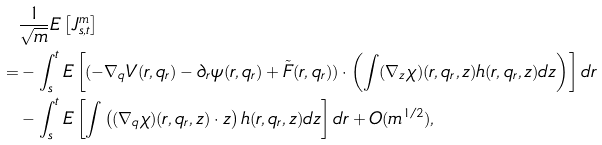Convert formula to latex. <formula><loc_0><loc_0><loc_500><loc_500>& \frac { 1 } { \sqrt { m } } E \left [ J _ { s , t } ^ { m } \right ] \\ = & - \int _ { s } ^ { t } E \left [ ( - \nabla _ { q } V ( r , q _ { r } ) - \partial _ { r } \psi ( r , q _ { r } ) + \tilde { F } ( r , q _ { r } ) ) \cdot \left ( \int ( \nabla _ { z } \chi ) ( r , q _ { r } , z ) h ( r , q _ { r } , z ) d z \right ) \right ] d r \\ & - \int _ { s } ^ { t } E \left [ \int \left ( ( \nabla _ { q } \chi ) ( r , q _ { r } , z ) \cdot z \right ) h ( r , q _ { r } , z ) d z \right ] d r + O ( m ^ { 1 / 2 } ) ,</formula> 